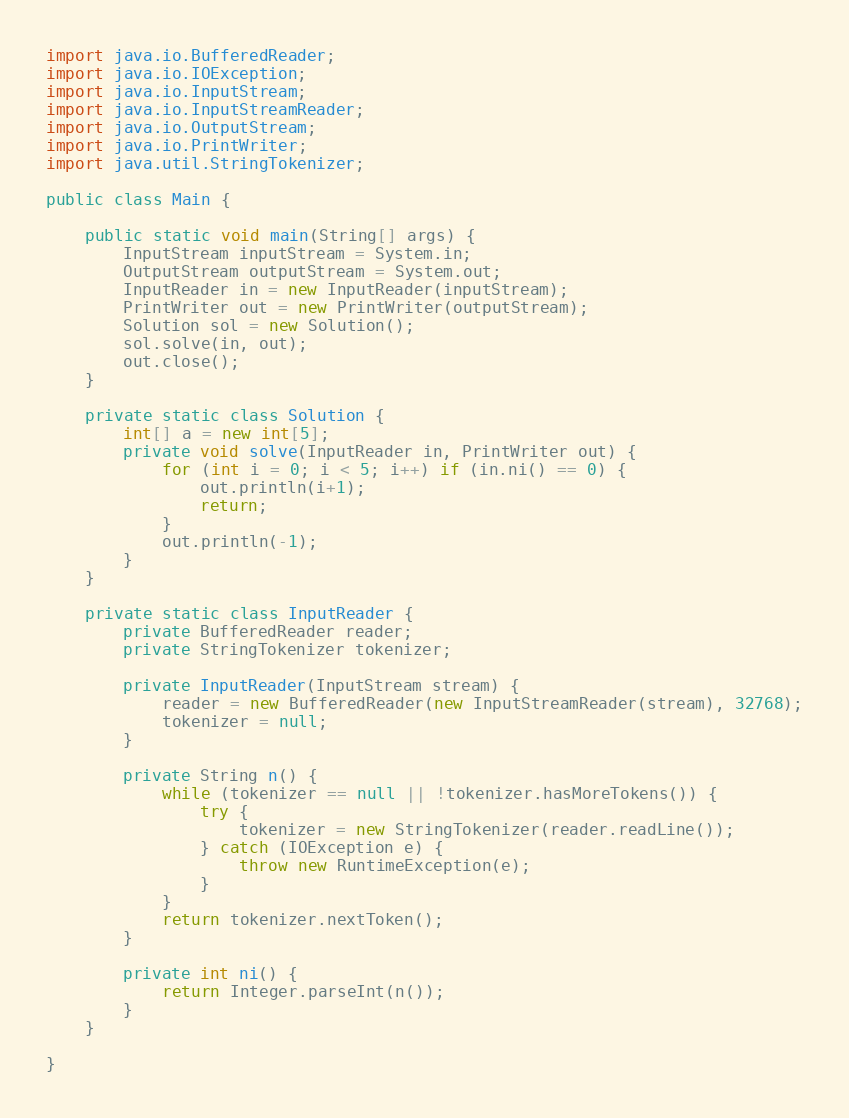Convert code to text. <code><loc_0><loc_0><loc_500><loc_500><_Java_>import java.io.BufferedReader;
import java.io.IOException;
import java.io.InputStream;
import java.io.InputStreamReader;
import java.io.OutputStream;
import java.io.PrintWriter;
import java.util.StringTokenizer;

public class Main {
	
	public static void main(String[] args) {
		InputStream inputStream = System.in;
		OutputStream outputStream = System.out;
		InputReader in = new InputReader(inputStream);
		PrintWriter out = new PrintWriter(outputStream);
		Solution sol = new Solution();
		sol.solve(in, out);
		out.close();
	}

	private static class Solution {
		int[] a = new int[5];
		private void solve(InputReader in, PrintWriter out) {
			for (int i = 0; i < 5; i++) if (in.ni() == 0) {
				out.println(i+1);
				return;
			}
			out.println(-1);
		}
	}

	private static class InputReader {
		private BufferedReader reader;
		private StringTokenizer tokenizer;

		private InputReader(InputStream stream) {
			reader = new BufferedReader(new InputStreamReader(stream), 32768);
			tokenizer = null;
		}

		private String n() {
			while (tokenizer == null || !tokenizer.hasMoreTokens()) {
				try {
					tokenizer = new StringTokenizer(reader.readLine());
				} catch (IOException e) {
					throw new RuntimeException(e);
				}
			}
			return tokenizer.nextToken();
		}

		private int ni() {
			return Integer.parseInt(n());
		}
	}

}
</code> 